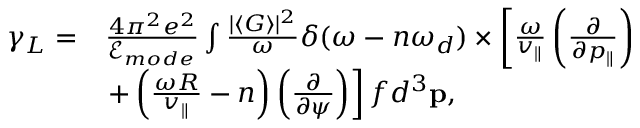<formula> <loc_0><loc_0><loc_500><loc_500>\begin{array} { r l } { \gamma _ { L } = } & { \frac { 4 \pi ^ { 2 } e ^ { 2 } } { \mathcal { E } _ { m o d e } } \int \frac { | \langle G \rangle | ^ { 2 } } { \omega } \delta ( \omega - n \omega _ { d } ) \times \left [ \frac { \omega } { v _ { \| } } \left ( \frac { \partial } { \partial p _ { \| } } \right ) } \\ & { + \left ( \frac { \omega R } { v _ { \| } } - n \right ) \left ( \frac { \partial } { \partial \psi } \right ) \right ] f d ^ { 3 } p , } \end{array}</formula> 